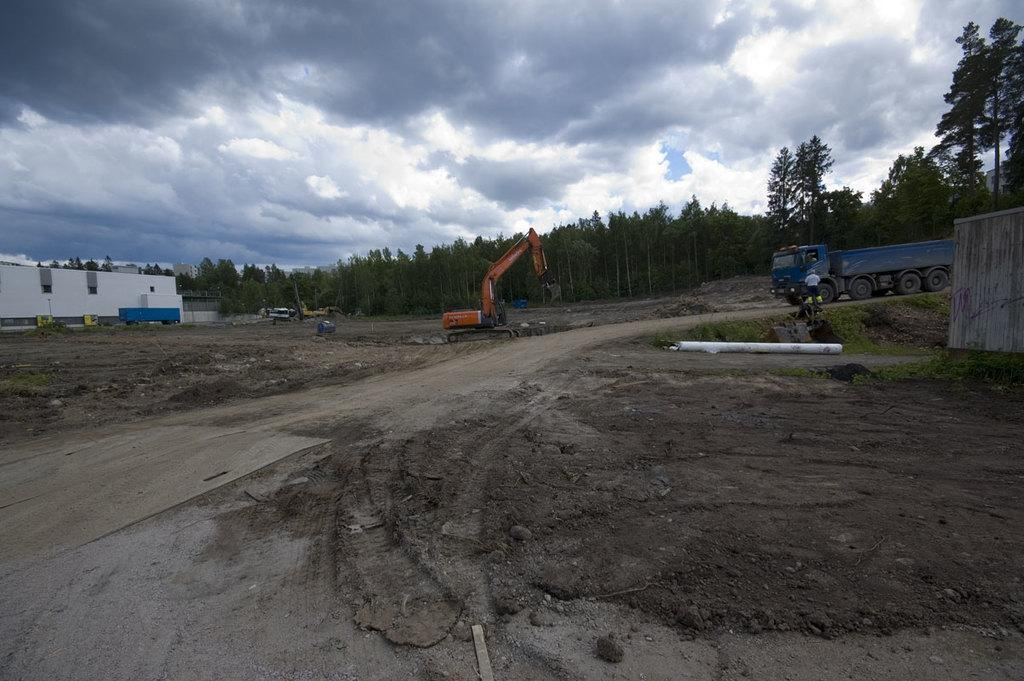What types of objects can be seen in the image? There are vehicles, buildings, and trees in the image. What is visible in the background of the image? The sky is visible in the background of the image. What type of channel can be seen in the image? There is no channel present in the image; it features vehicles, buildings, trees, and the sky. What kind of map is visible in the image? There is no map present in the image; it features vehicles, buildings, trees, and the sky. 